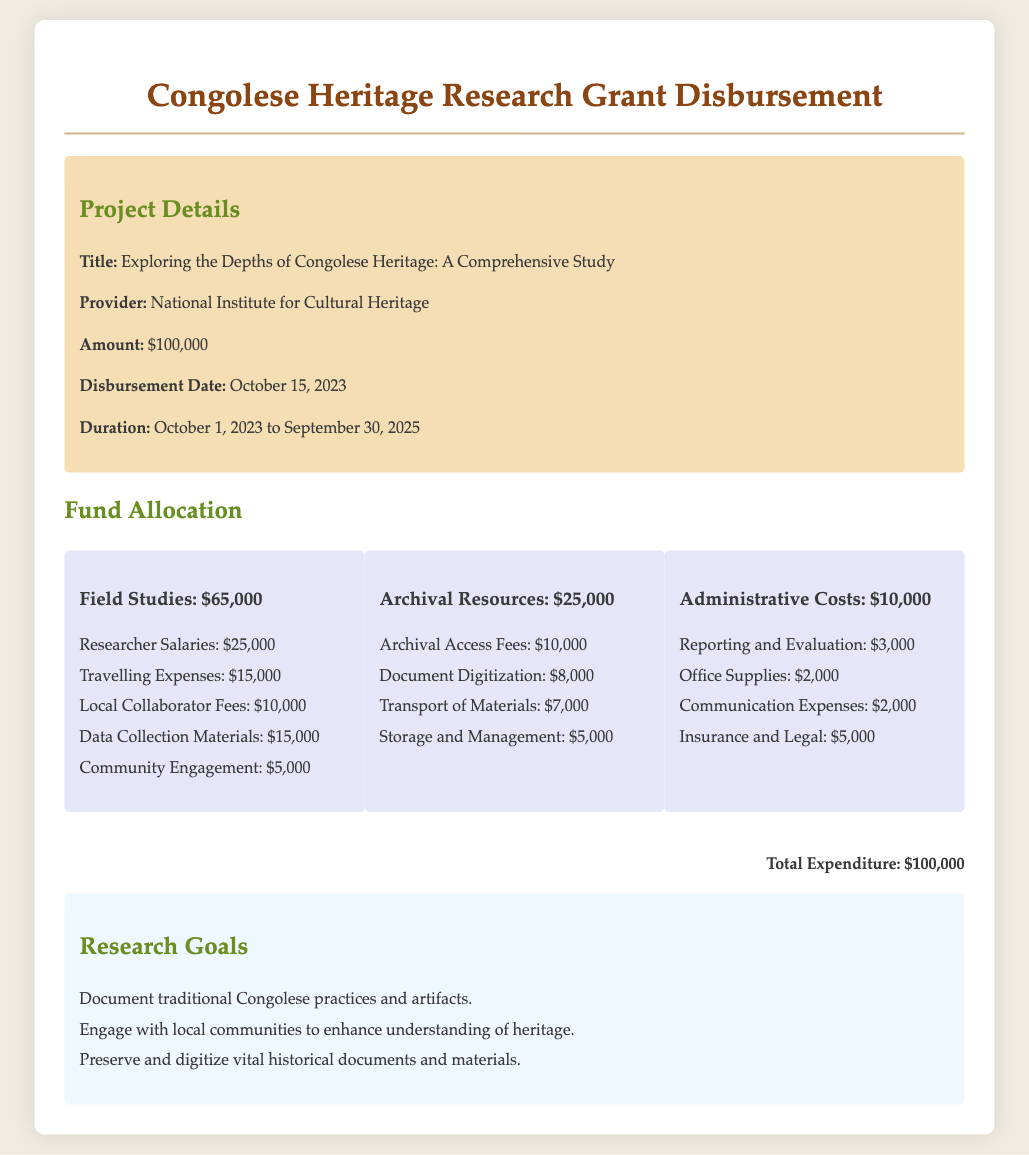what is the title of the project? The title of the project is provided in the document under Project Details.
Answer: Exploring the Depths of Congolese Heritage: A Comprehensive Study who is the provider of the grant? The provider of the grant is mentioned in the Project Details section.
Answer: National Institute for Cultural Heritage how much funding is allocated for field studies? The amount allocated for field studies is specified in the Fund Allocation section.
Answer: $65,000 what percentage of the total amount is spent on archival resources? The archival resources allocation is related to the total funding, requiring simple calculation: (25,000 / 100,000) * 100%.
Answer: 25% what are the total administrative costs? Administrative costs are listed separately in the Fund Allocation section and summed to find the total.
Answer: $10,000 how long is the duration of the project? The duration of the project is clearly stated in the Project Details section of the document.
Answer: October 1, 2023 to September 30, 2025 what is the total expenditure stated in the document? The total expenditure is summarized at the end of the document and matches the overall funding.
Answer: $100,000 what is the purpose of community engagement in field studies? The document gives specific allocations under field studies, mentioning community engagement as one of the categories listed.
Answer: $5,000 how much is allocated for document digitization? The amount allocated for document digitization is mentioned under the Archival Resources section.
Answer: $8,000 